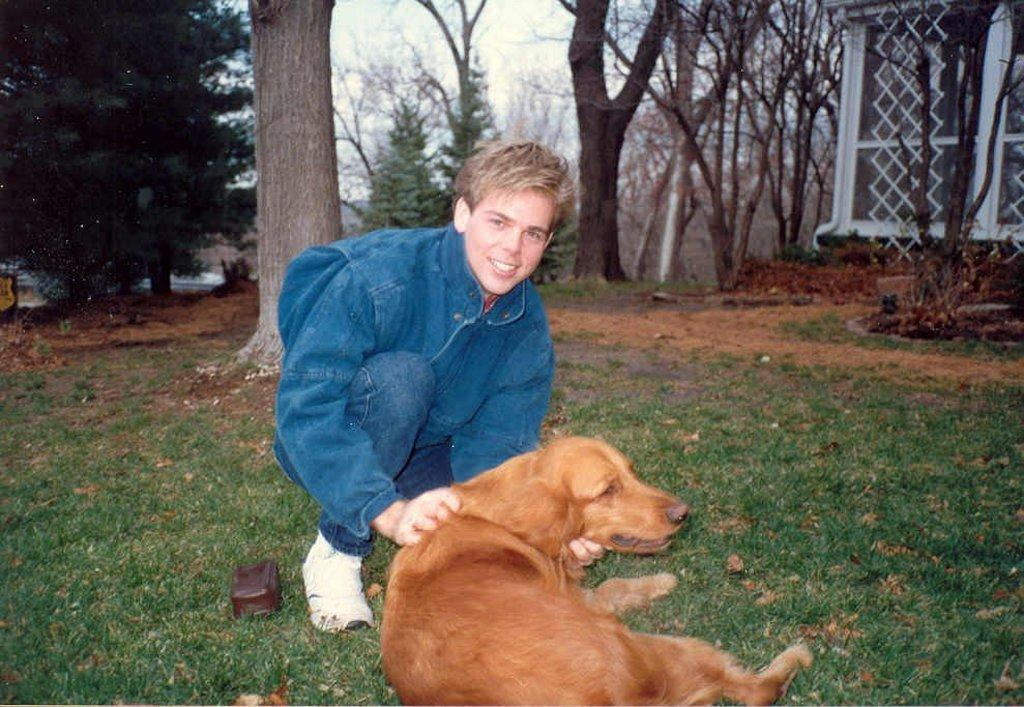Who is present in the image? There is a boy in the image. What is the boy doing in the image? The boy is sitting on the grass. What is in front of the boy? There is a dog in front of the boy. What can be seen in the background of the image? There are trees and a wall in the background of the image. What part of the natural environment is visible in the image? The sky is visible in the image. Where is the shelf located in the image? There is no shelf present in the image. Is there a mailbox visible in the image? No, there is no mailbox visible in the image. 